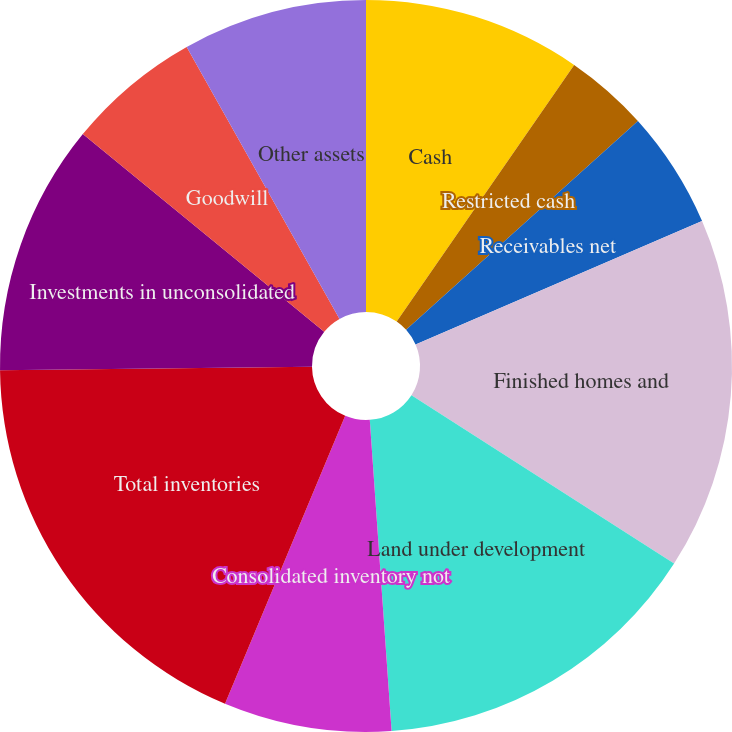Convert chart to OTSL. <chart><loc_0><loc_0><loc_500><loc_500><pie_chart><fcel>Cash<fcel>Restricted cash<fcel>Receivables net<fcel>Finished homes and<fcel>Land under development<fcel>Consolidated inventory not<fcel>Total inventories<fcel>Investments in unconsolidated<fcel>Goodwill<fcel>Other assets<nl><fcel>9.63%<fcel>3.7%<fcel>5.19%<fcel>15.56%<fcel>14.81%<fcel>7.41%<fcel>18.52%<fcel>11.11%<fcel>5.93%<fcel>8.15%<nl></chart> 